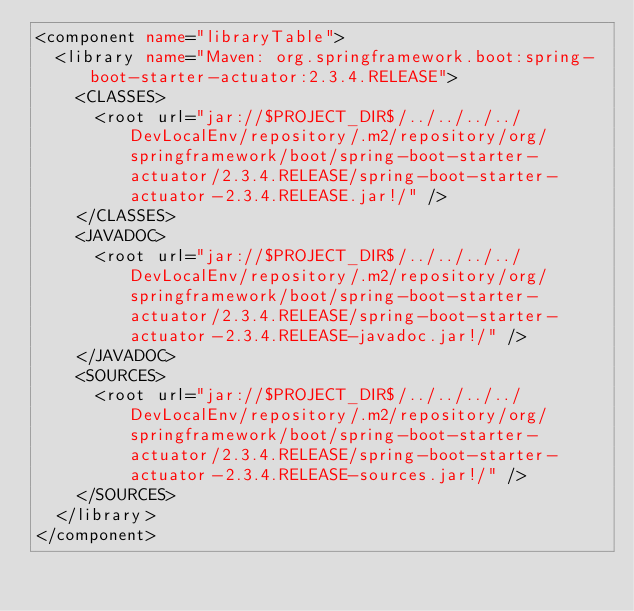Convert code to text. <code><loc_0><loc_0><loc_500><loc_500><_XML_><component name="libraryTable">
  <library name="Maven: org.springframework.boot:spring-boot-starter-actuator:2.3.4.RELEASE">
    <CLASSES>
      <root url="jar://$PROJECT_DIR$/../../../../DevLocalEnv/repository/.m2/repository/org/springframework/boot/spring-boot-starter-actuator/2.3.4.RELEASE/spring-boot-starter-actuator-2.3.4.RELEASE.jar!/" />
    </CLASSES>
    <JAVADOC>
      <root url="jar://$PROJECT_DIR$/../../../../DevLocalEnv/repository/.m2/repository/org/springframework/boot/spring-boot-starter-actuator/2.3.4.RELEASE/spring-boot-starter-actuator-2.3.4.RELEASE-javadoc.jar!/" />
    </JAVADOC>
    <SOURCES>
      <root url="jar://$PROJECT_DIR$/../../../../DevLocalEnv/repository/.m2/repository/org/springframework/boot/spring-boot-starter-actuator/2.3.4.RELEASE/spring-boot-starter-actuator-2.3.4.RELEASE-sources.jar!/" />
    </SOURCES>
  </library>
</component></code> 